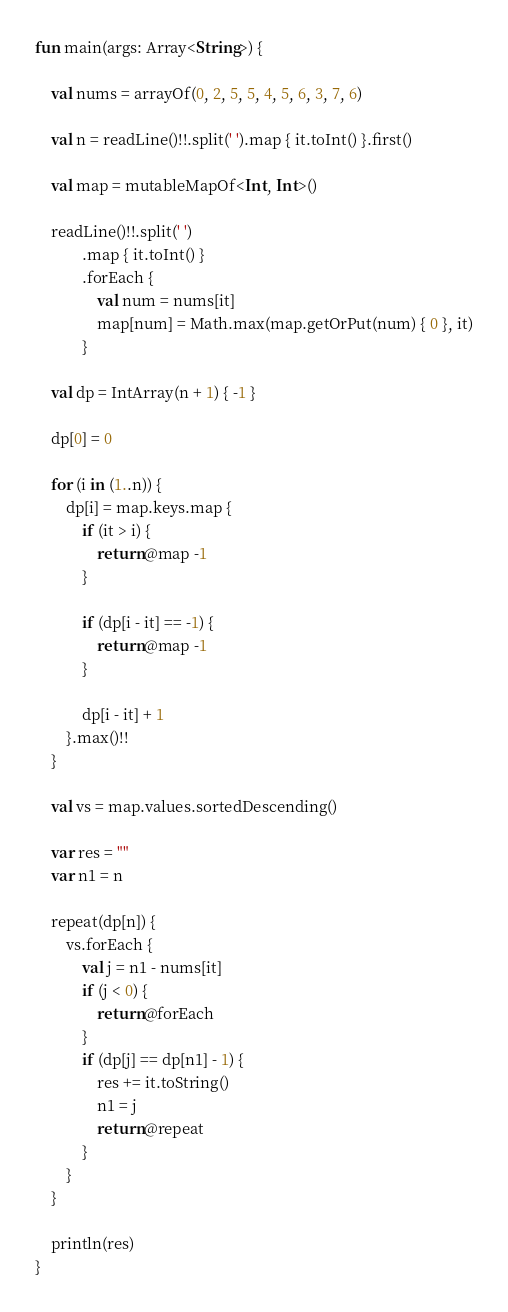Convert code to text. <code><loc_0><loc_0><loc_500><loc_500><_Kotlin_>fun main(args: Array<String>) {

    val nums = arrayOf(0, 2, 5, 5, 4, 5, 6, 3, 7, 6)

    val n = readLine()!!.split(' ').map { it.toInt() }.first()

    val map = mutableMapOf<Int, Int>()

    readLine()!!.split(' ')
            .map { it.toInt() }
            .forEach {
                val num = nums[it]
                map[num] = Math.max(map.getOrPut(num) { 0 }, it)
            }

    val dp = IntArray(n + 1) { -1 }

    dp[0] = 0

    for (i in (1..n)) {
        dp[i] = map.keys.map {
            if (it > i) {
                return@map -1
            }

            if (dp[i - it] == -1) {
                return@map -1
            }

            dp[i - it] + 1
        }.max()!!
    }

    val vs = map.values.sortedDescending()

    var res = ""
    var n1 = n

    repeat(dp[n]) {
        vs.forEach {
            val j = n1 - nums[it]
            if (j < 0) {
                return@forEach
            }
            if (dp[j] == dp[n1] - 1) {
                res += it.toString()
                n1 = j
                return@repeat
            }
        }
    }

    println(res)
}
</code> 